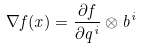<formula> <loc_0><loc_0><loc_500><loc_500>\nabla f ( x ) = \frac { \partial f } { \partial q ^ { i } } \otimes b ^ { i }</formula> 